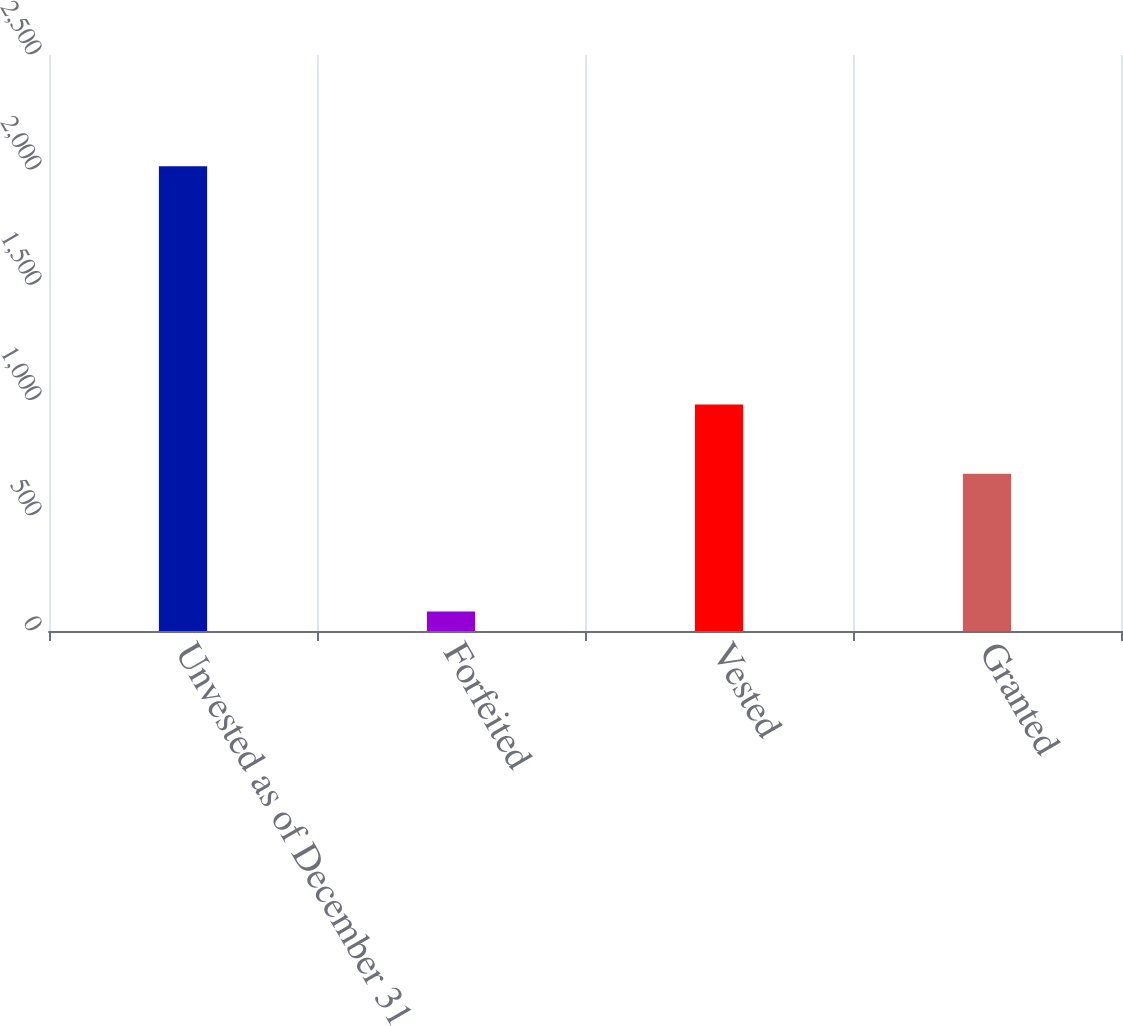<chart> <loc_0><loc_0><loc_500><loc_500><bar_chart><fcel>Unvested as of December 31<fcel>Forfeited<fcel>Vested<fcel>Granted<nl><fcel>2017<fcel>85<fcel>983.5<fcel>682<nl></chart> 